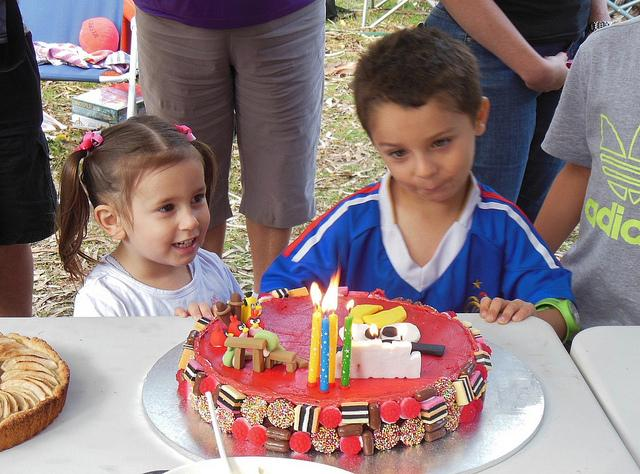When will this girl be old enough for Kindergarten? Please explain your reasoning. 1 year. Kindergarten is for five year olds. there are four candles on the cake. 